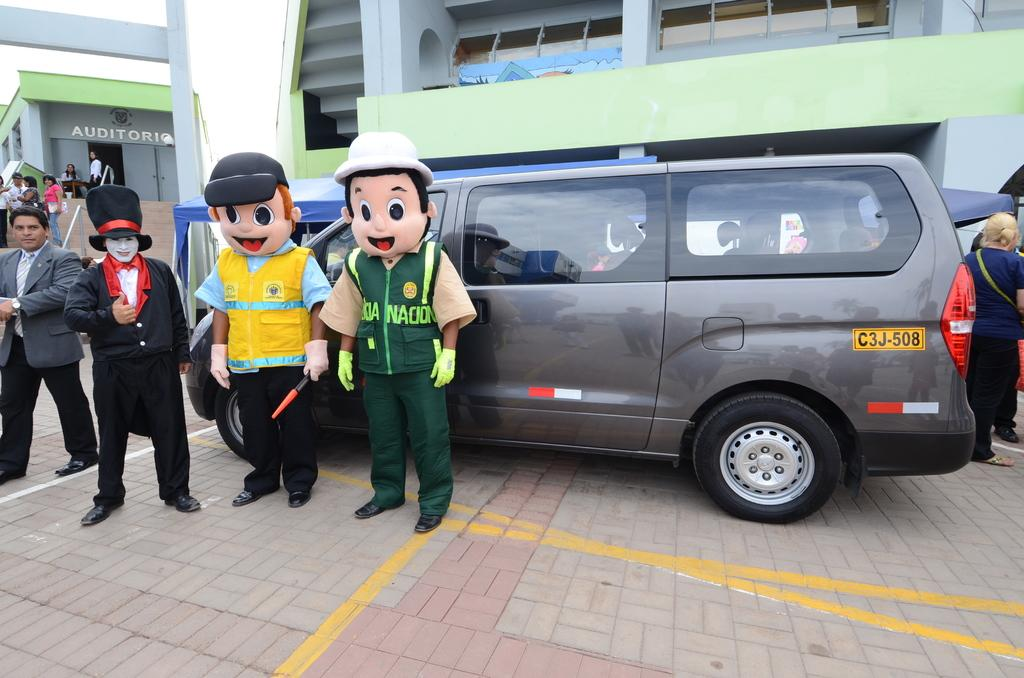What is happening on the floor in the image? There are people standing on a floor in the image. What are some of the people wearing? Some of the people are wearing costumes. What else can be seen on the floor? There is a vehicle on the floor. What can be seen in the distance in the image? There are buildings in the background of the image. What type of meal is being prepared in the image? There is no meal preparation visible in the image. How does the vehicle stop in the image? The vehicle does not move in the image; it is stationary on the floor. 